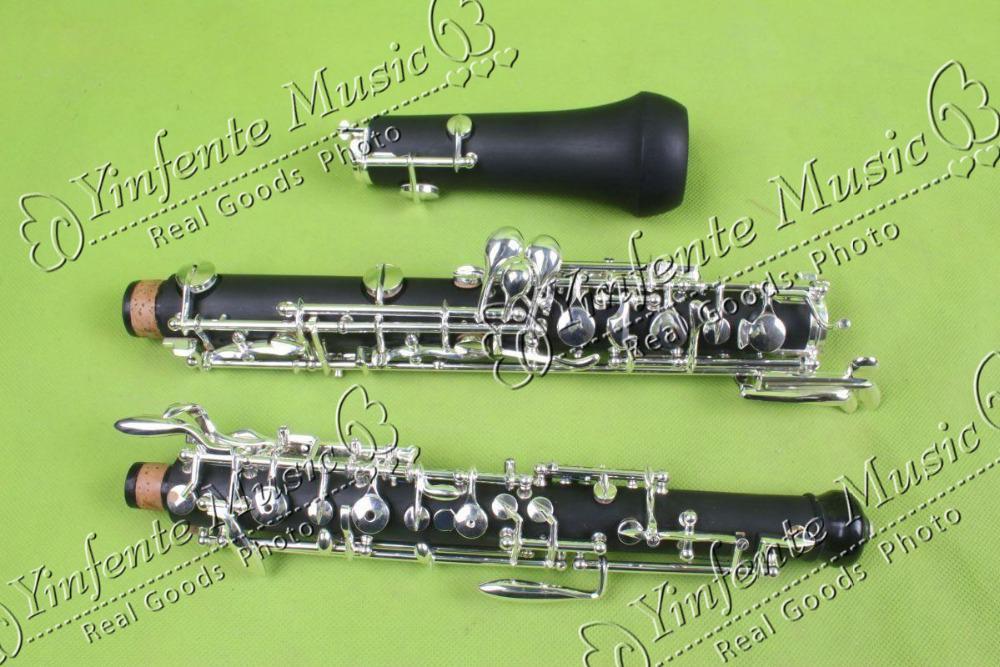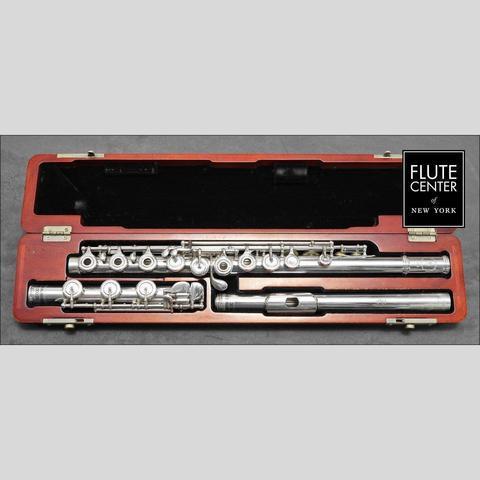The first image is the image on the left, the second image is the image on the right. Analyze the images presented: Is the assertion "One of the flutes is blue." valid? Answer yes or no. No. The first image is the image on the left, the second image is the image on the right. For the images displayed, is the sentence "One image shows a disassembled instrument in an open case displayed horizontally, and the other image shows items that are not in a case." factually correct? Answer yes or no. Yes. 